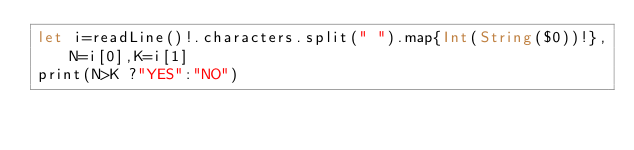<code> <loc_0><loc_0><loc_500><loc_500><_Swift_>let i=readLine()!.characters.split(" ").map{Int(String($0))!},N=i[0],K=i[1]
print(N>K ?"YES":"NO")</code> 